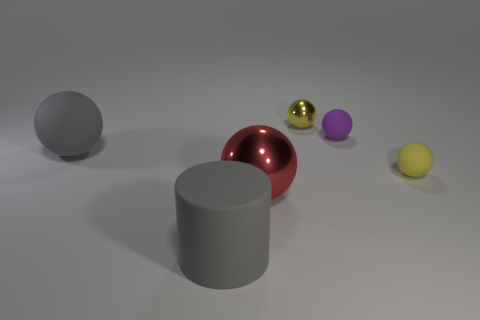Are there an equal number of big red spheres behind the yellow metallic ball and large matte spheres on the left side of the red object?
Your answer should be compact. No. The large metallic object that is the same shape as the tiny purple rubber thing is what color?
Your response must be concise. Red. Is there any other thing that is the same shape as the purple rubber thing?
Offer a terse response. Yes. Do the matte sphere that is in front of the large gray matte sphere and the tiny shiny ball have the same color?
Give a very brief answer. Yes. There is a yellow shiny object that is the same shape as the large red object; what size is it?
Give a very brief answer. Small. How many other cylinders are the same material as the gray cylinder?
Give a very brief answer. 0. Are there any big things behind the large matte thing on the right side of the gray rubber thing to the left of the big gray matte cylinder?
Keep it short and to the point. Yes. The yellow rubber thing is what shape?
Provide a succinct answer. Sphere. Do the gray thing right of the big gray sphere and the yellow thing that is in front of the tiny yellow metallic sphere have the same material?
Give a very brief answer. Yes. How many matte spheres are the same color as the tiny shiny sphere?
Offer a terse response. 1. 